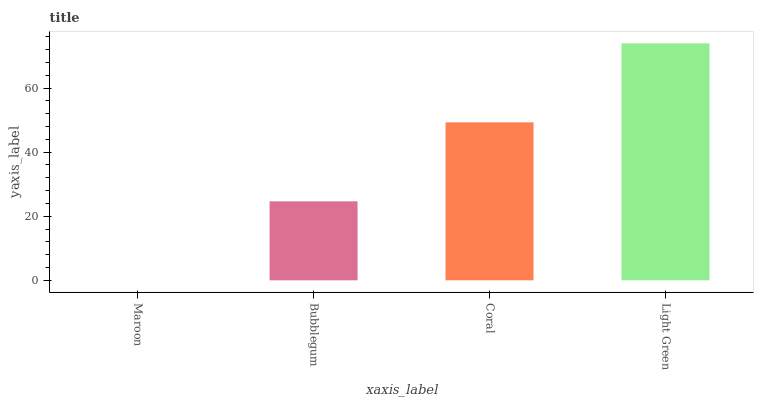Is Maroon the minimum?
Answer yes or no. Yes. Is Light Green the maximum?
Answer yes or no. Yes. Is Bubblegum the minimum?
Answer yes or no. No. Is Bubblegum the maximum?
Answer yes or no. No. Is Bubblegum greater than Maroon?
Answer yes or no. Yes. Is Maroon less than Bubblegum?
Answer yes or no. Yes. Is Maroon greater than Bubblegum?
Answer yes or no. No. Is Bubblegum less than Maroon?
Answer yes or no. No. Is Coral the high median?
Answer yes or no. Yes. Is Bubblegum the low median?
Answer yes or no. Yes. Is Light Green the high median?
Answer yes or no. No. Is Maroon the low median?
Answer yes or no. No. 